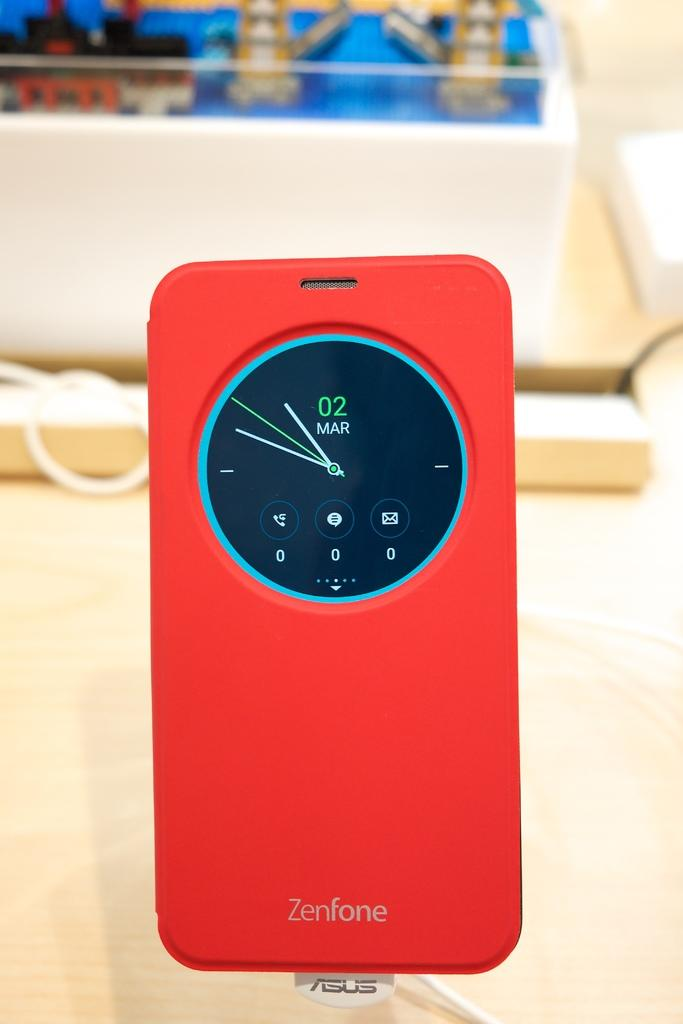<image>
Provide a brief description of the given image. A bright red wallet style cover on a Zenfone that has a cut out to show the clock and a hole for the speaker. 